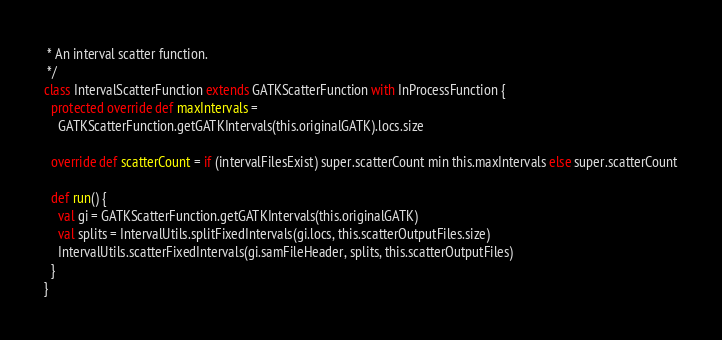Convert code to text. <code><loc_0><loc_0><loc_500><loc_500><_Scala_> * An interval scatter function.
 */
class IntervalScatterFunction extends GATKScatterFunction with InProcessFunction {
  protected override def maxIntervals =
    GATKScatterFunction.getGATKIntervals(this.originalGATK).locs.size

  override def scatterCount = if (intervalFilesExist) super.scatterCount min this.maxIntervals else super.scatterCount

  def run() {
    val gi = GATKScatterFunction.getGATKIntervals(this.originalGATK)
    val splits = IntervalUtils.splitFixedIntervals(gi.locs, this.scatterOutputFiles.size)
    IntervalUtils.scatterFixedIntervals(gi.samFileHeader, splits, this.scatterOutputFiles)
  }
}
</code> 